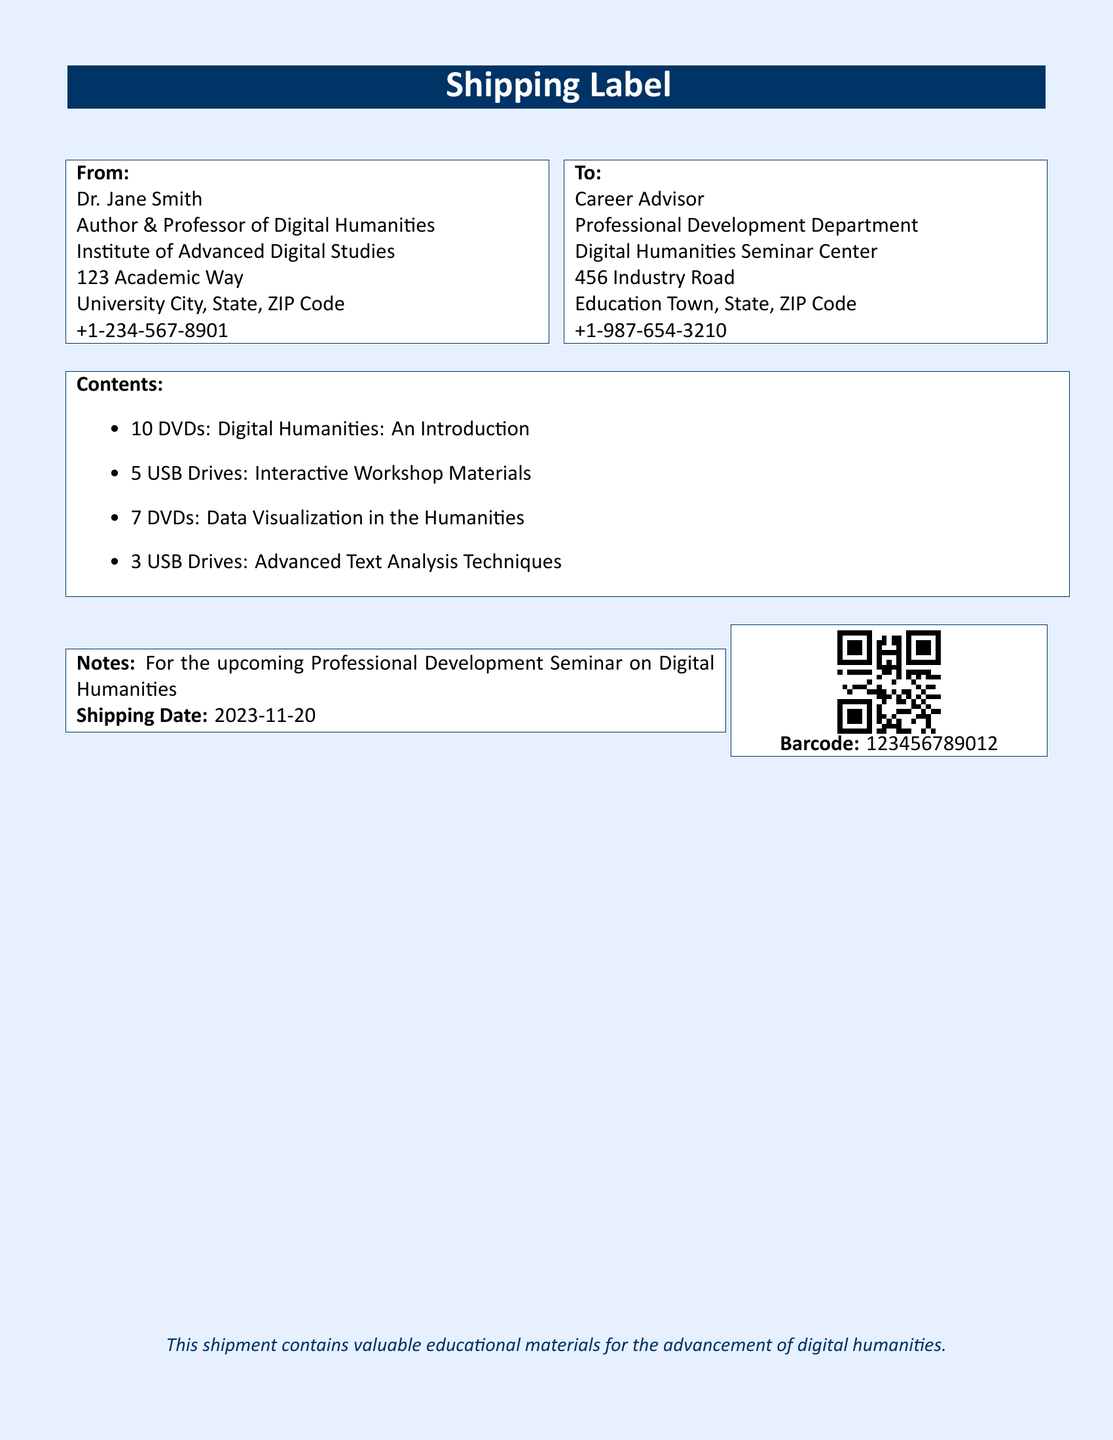What is the name of the sender? The sender is identified in the "From" section of the document.
Answer: Dr. Jane Smith What is the total number of DVDs being shipped? The total is calculated by adding the number of DVDs listed in the "Contents" section.
Answer: 20 DVDs What is the shipping date? The shipping date is specified in the "Notes" section of the document.
Answer: 2023-11-20 Who is the recipient of this shipment? The recipient is mentioned in the "To" section of the document.
Answer: Career Advisor How many USB drives contain interactive workshop materials? The number of USB drives is found in the "Contents" section.
Answer: 5 USB Drives What is the barcode number associated with this shipment? The barcode number is provided in the "Barcode" section and is crucial for inventory management.
Answer: 123456789012 What is the purpose of the shipment? The purpose of the shipment is indicated in the "Notes" section.
Answer: Professional Development Seminar on Digital Humanities How many types of media are included in the shipment? The types of media can be identified from the items listed in the "Contents" section.
Answer: 2 types (DVDs and USB Drives) What institution is Dr. Jane Smith affiliated with? The institution is stated under the "From" section of the label.
Answer: Institute of Advanced Digital Studies 